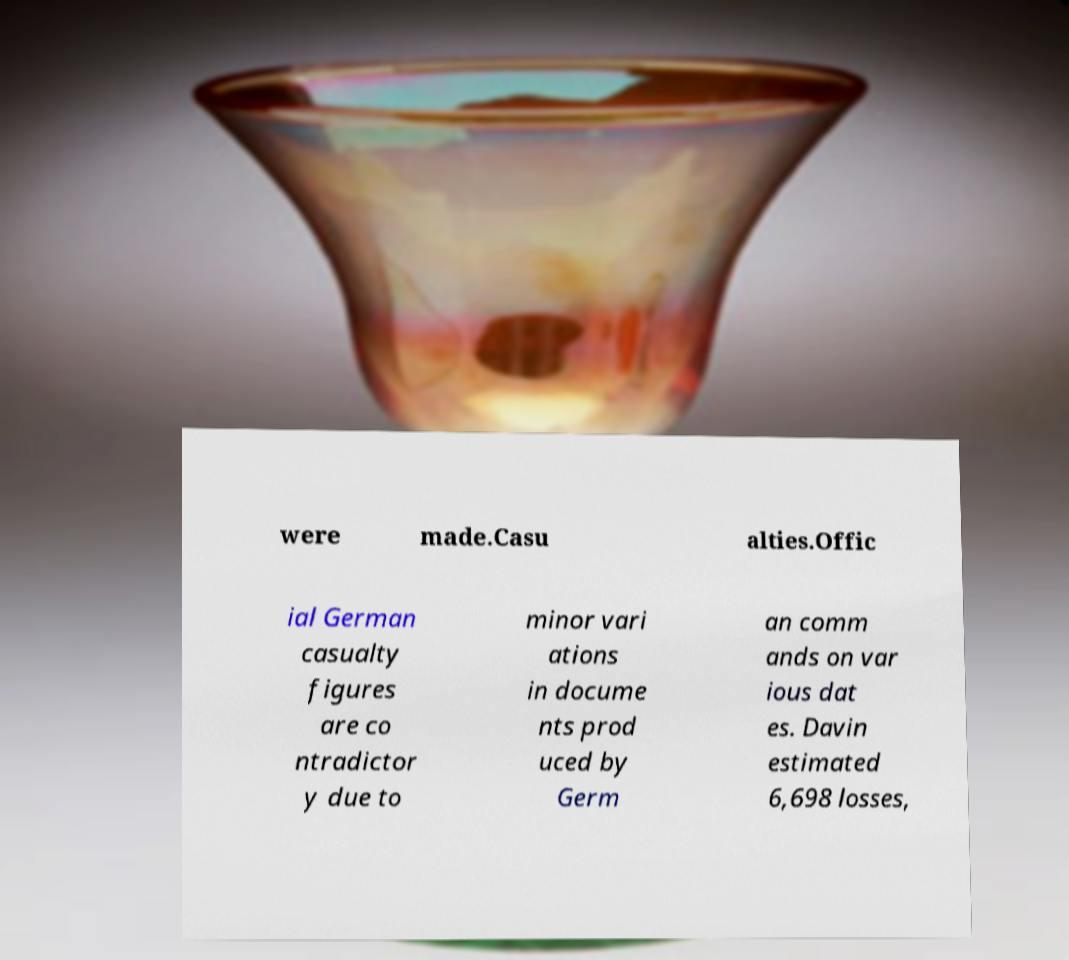Can you accurately transcribe the text from the provided image for me? were made.Casu alties.Offic ial German casualty figures are co ntradictor y due to minor vari ations in docume nts prod uced by Germ an comm ands on var ious dat es. Davin estimated 6,698 losses, 